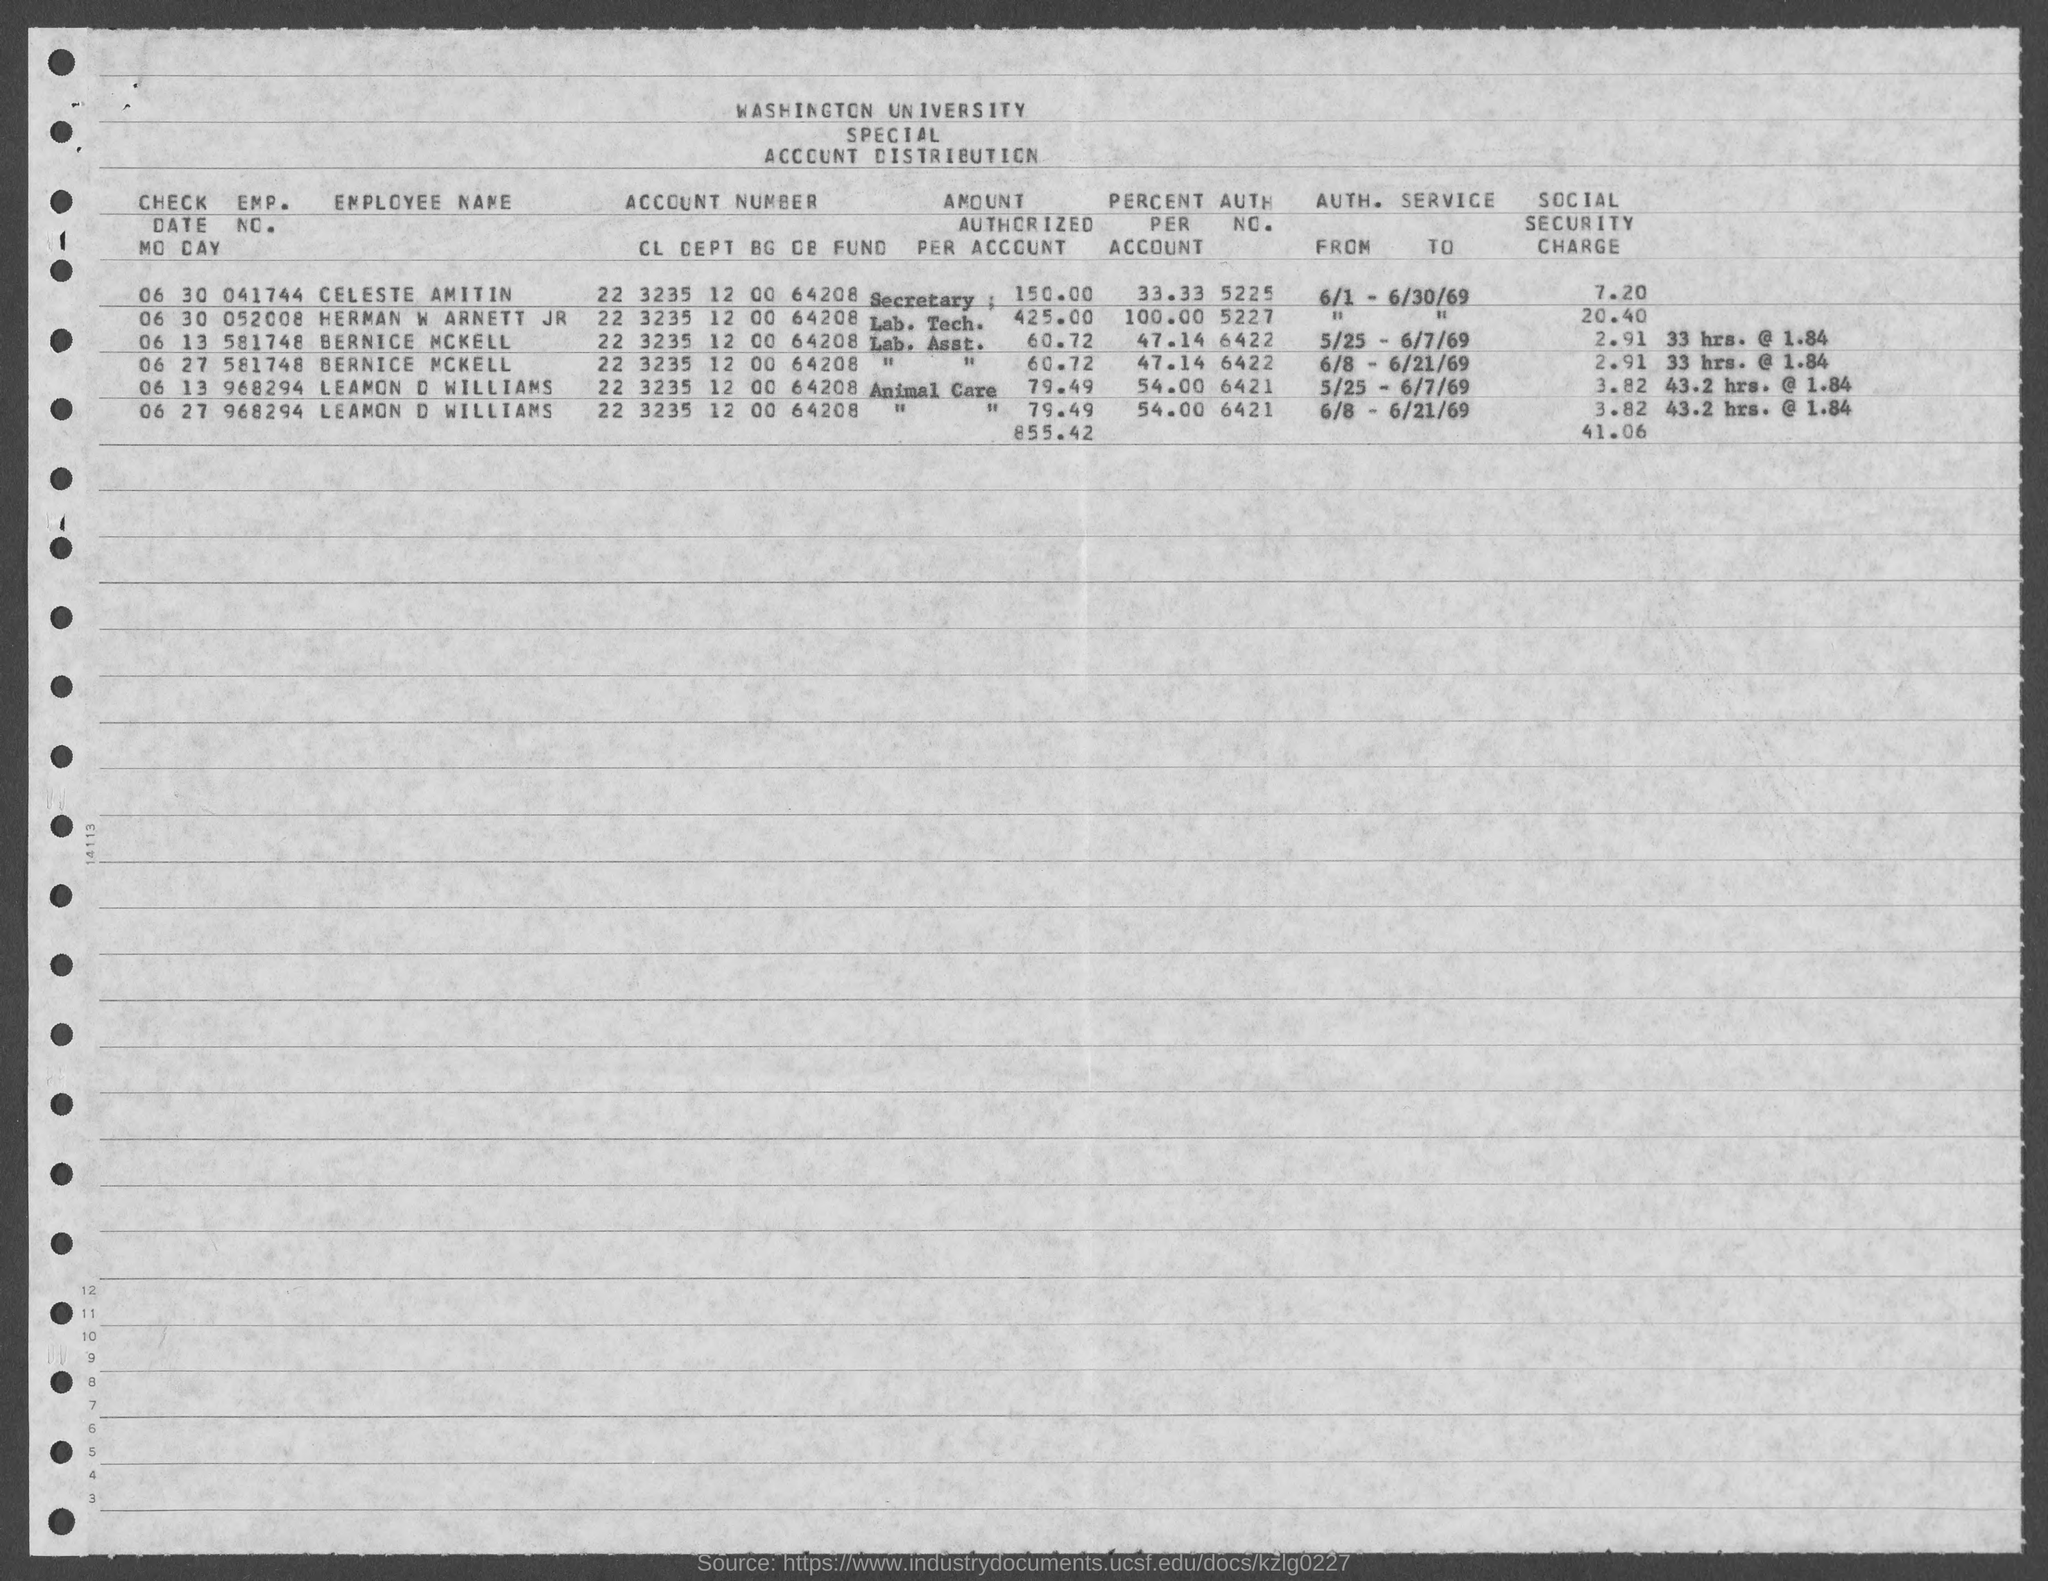What is the name of the university mentioned in the given form ?
Offer a terse response. WASHINGTON UNIVERSITY. What is the emp. no. of bernice mckell as mentioned in the given form ?
Make the answer very short. 581748. What is the emp. no. of leamon d williams ?
Make the answer very short. 968294. What is the emp. no. of herman w arnett jr ?
Make the answer very short. 052008. What is the emp. no. of celeste amitin ?
Provide a short and direct response. 041744. What is the auth no. for celeste amitin ?
Give a very brief answer. 5225. What is the auth no. for bernice mckell ?
Your answer should be very brief. 6422. What is the auth no. for leamon d williams ?
Provide a short and direct response. 6421. What is the value of percent per account for bernice mckell as mentioned in the given form ?
Your answer should be very brief. 47.14. What is the value of percent per account for celeste amitin as mentioned in the given form ?
Ensure brevity in your answer.  33.33. 